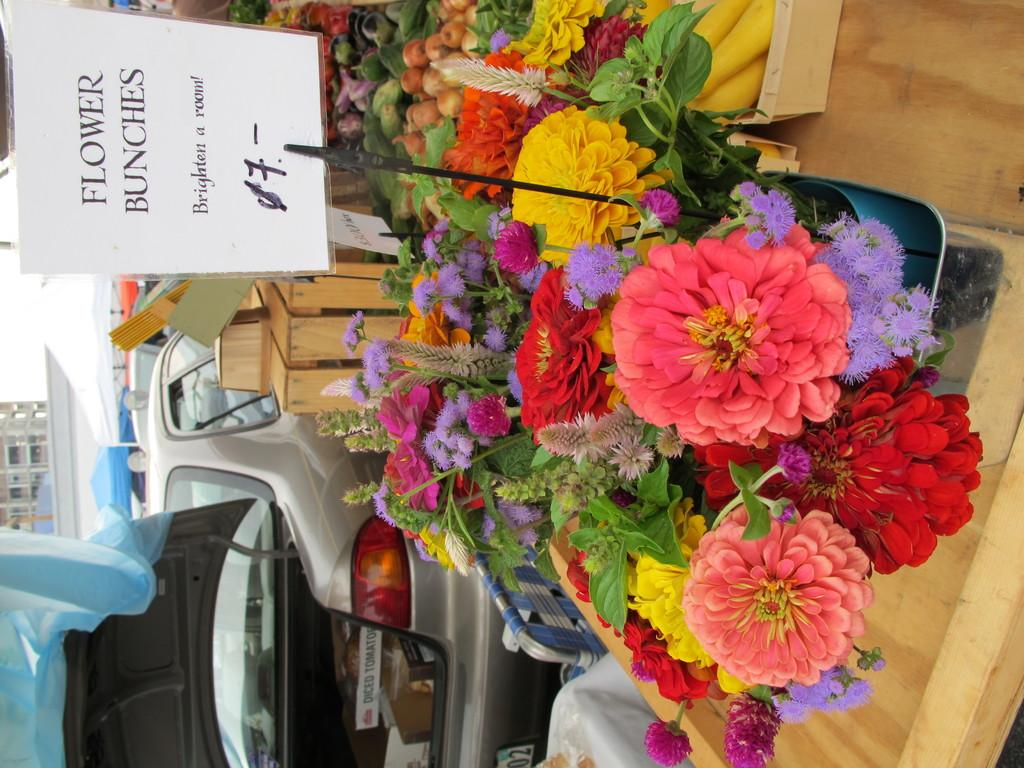What is placed in a tray in the image? There are flower bouquets in a tray in the image. What is the tray placed on? The tray is on a wooden table. What can be seen in the background of the image? There are cars on the road and a building in the background. How is the image oriented? The image is in a vertical orientation. How many firemen are visible in the image? There are no firemen present in the image. What type of cemetery can be seen in the image? There is no cemetery present in the image. 